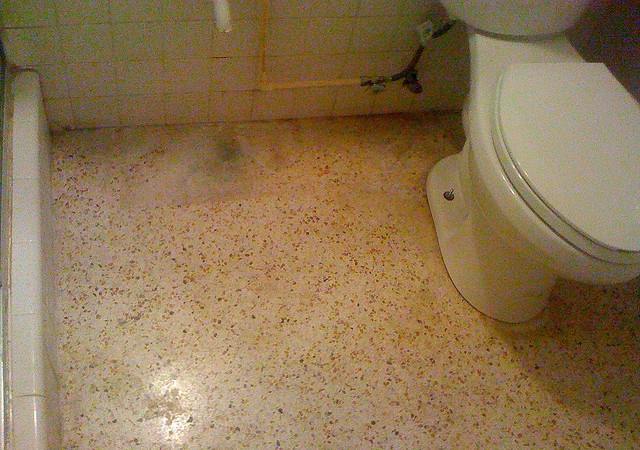Describe the objects in this image and their specific colors. I can see a toilet in purple, darkgray, tan, olive, and gray tones in this image. 